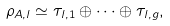Convert formula to latex. <formula><loc_0><loc_0><loc_500><loc_500>\rho _ { A , l } \simeq \tau _ { l , 1 } \oplus \cdots \oplus \tau _ { l , g } ,</formula> 